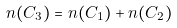<formula> <loc_0><loc_0><loc_500><loc_500>n ( C _ { 3 } ) = n ( C _ { 1 } ) + n ( C _ { 2 } ) \,</formula> 